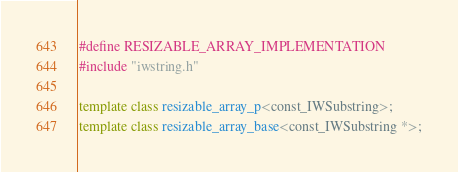Convert code to text. <code><loc_0><loc_0><loc_500><loc_500><_C++_>#define RESIZABLE_ARRAY_IMPLEMENTATION
#include "iwstring.h"

template class resizable_array_p<const_IWSubstring>;
template class resizable_array_base<const_IWSubstring *>;
</code> 